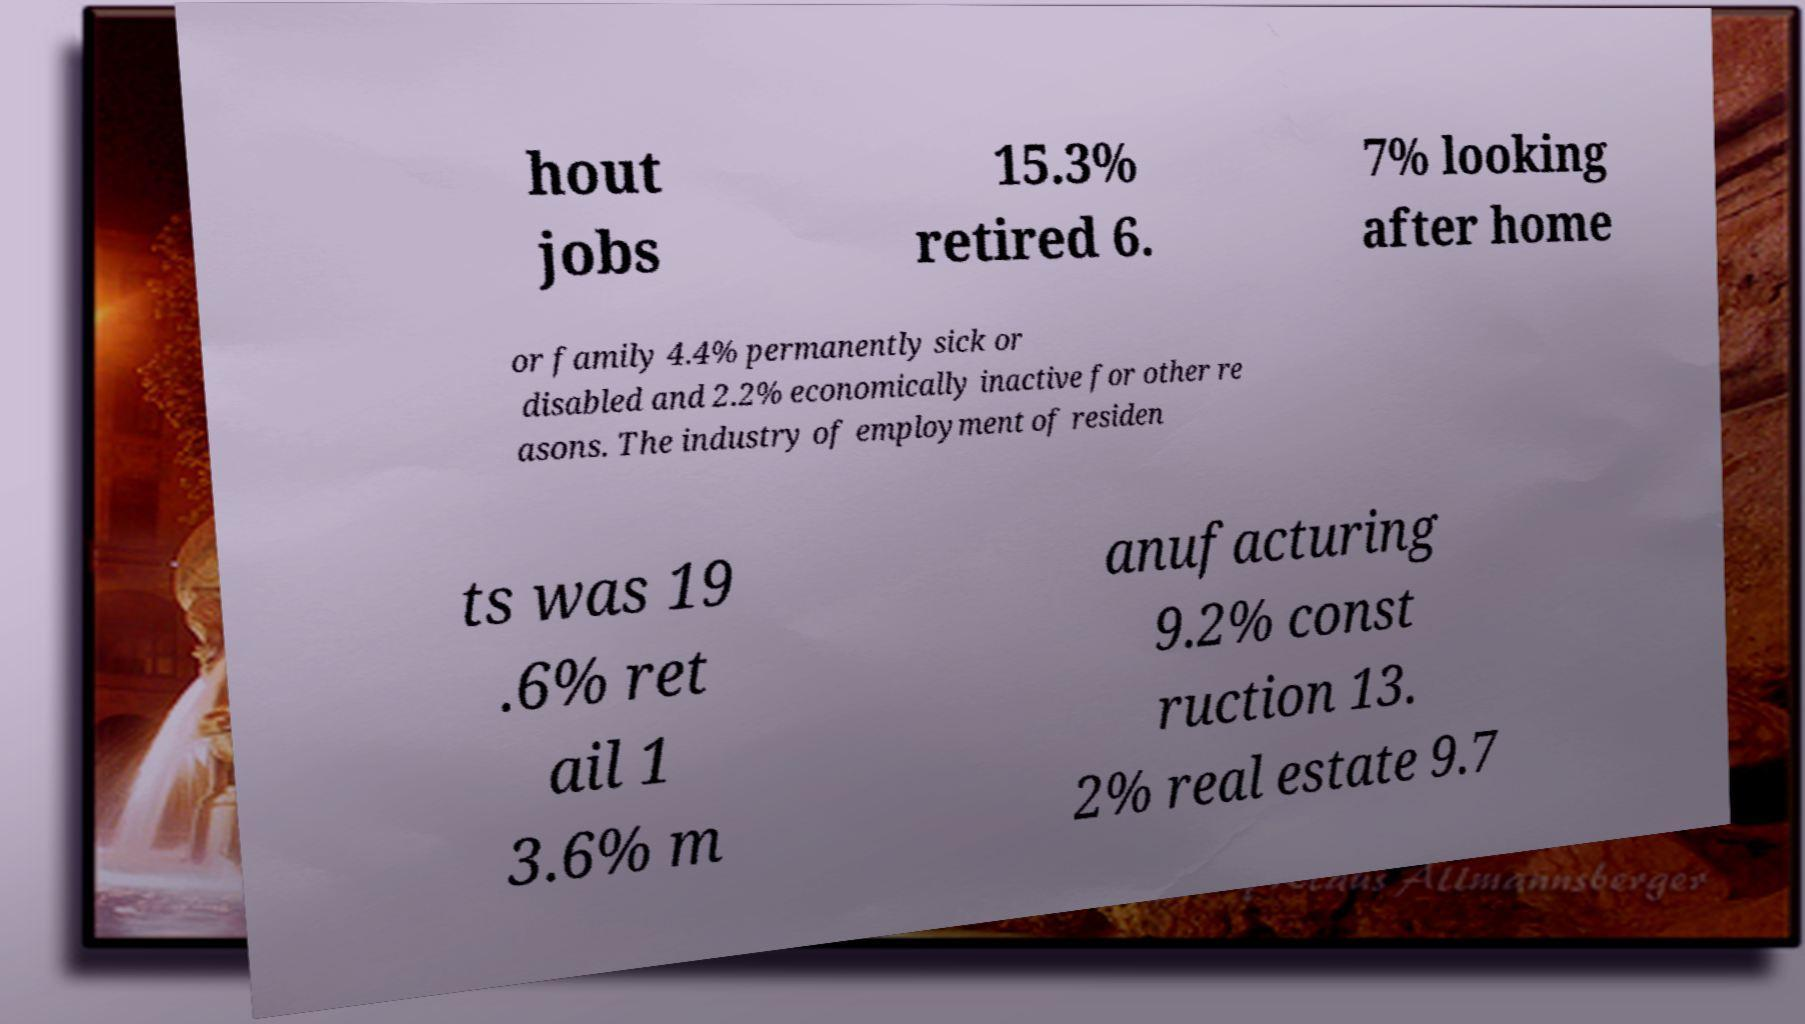What messages or text are displayed in this image? I need them in a readable, typed format. hout jobs 15.3% retired 6. 7% looking after home or family 4.4% permanently sick or disabled and 2.2% economically inactive for other re asons. The industry of employment of residen ts was 19 .6% ret ail 1 3.6% m anufacturing 9.2% const ruction 13. 2% real estate 9.7 